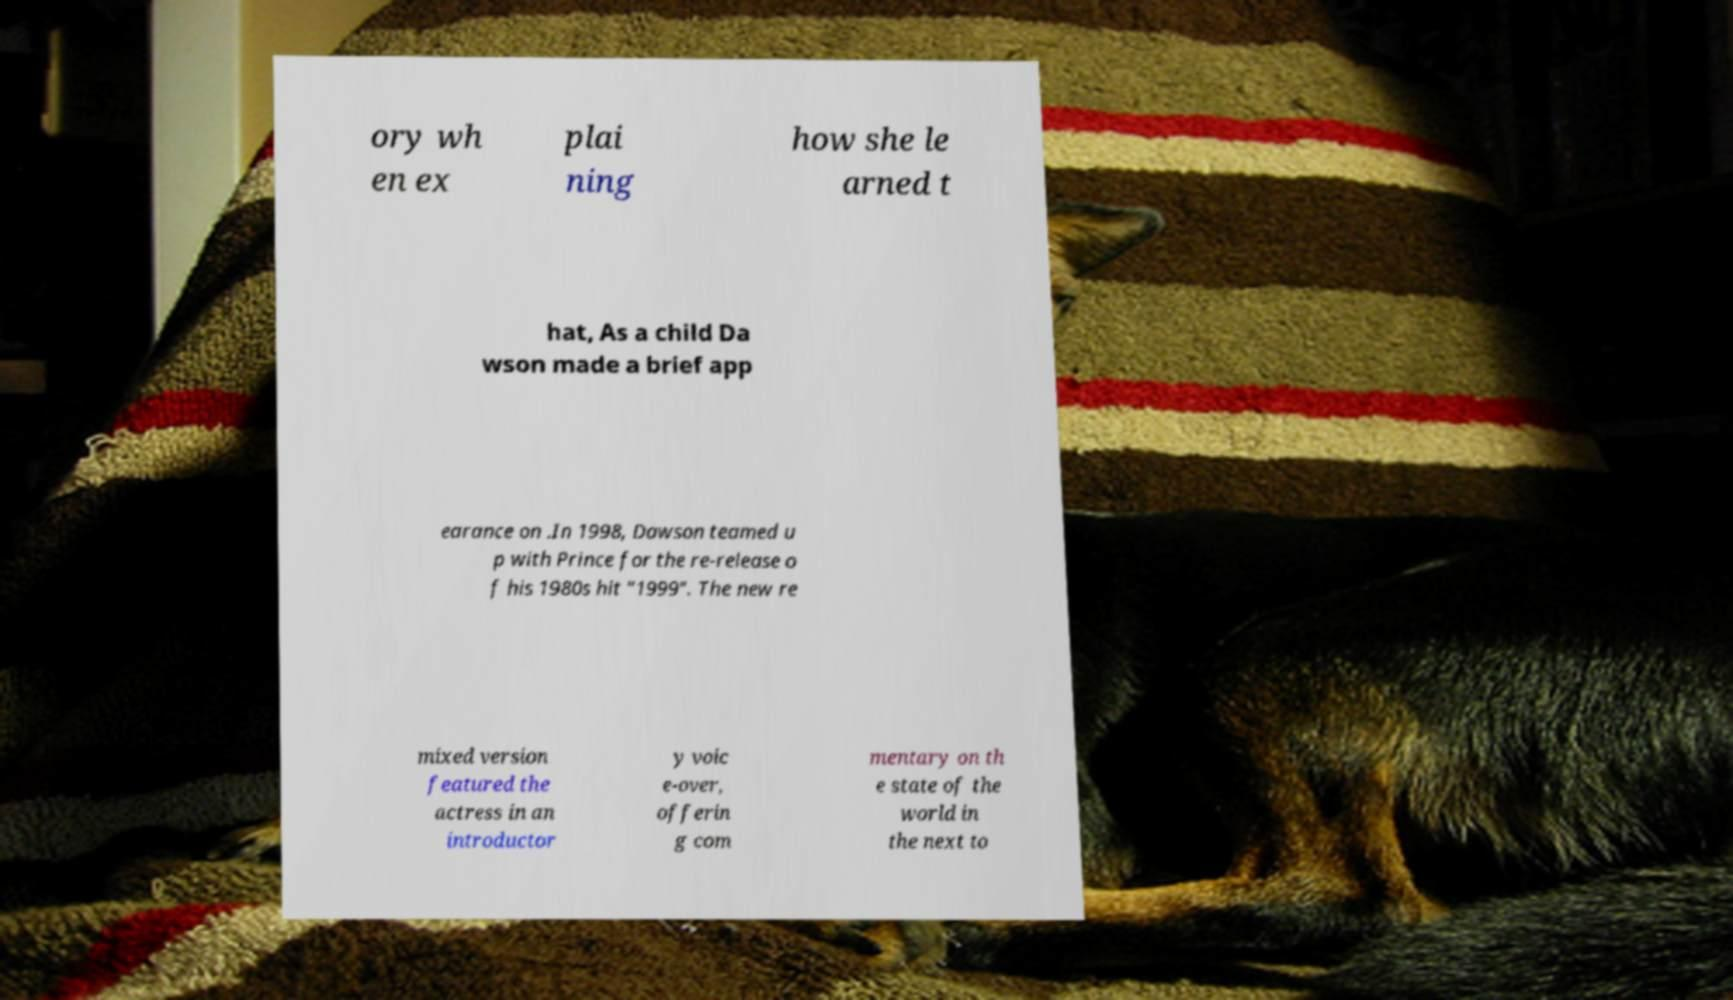What messages or text are displayed in this image? I need them in a readable, typed format. ory wh en ex plai ning how she le arned t hat, As a child Da wson made a brief app earance on .In 1998, Dawson teamed u p with Prince for the re-release o f his 1980s hit "1999". The new re mixed version featured the actress in an introductor y voic e-over, offerin g com mentary on th e state of the world in the next to 